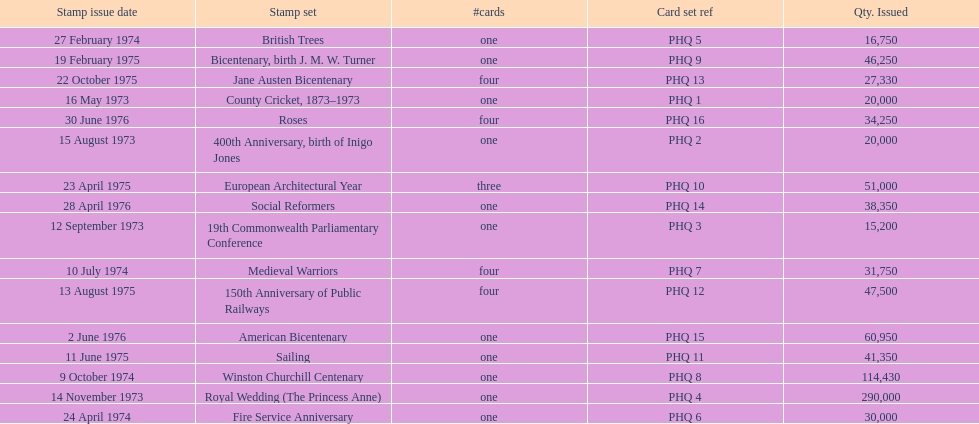Which stamp set had the greatest quantity issued? Royal Wedding (The Princess Anne). 